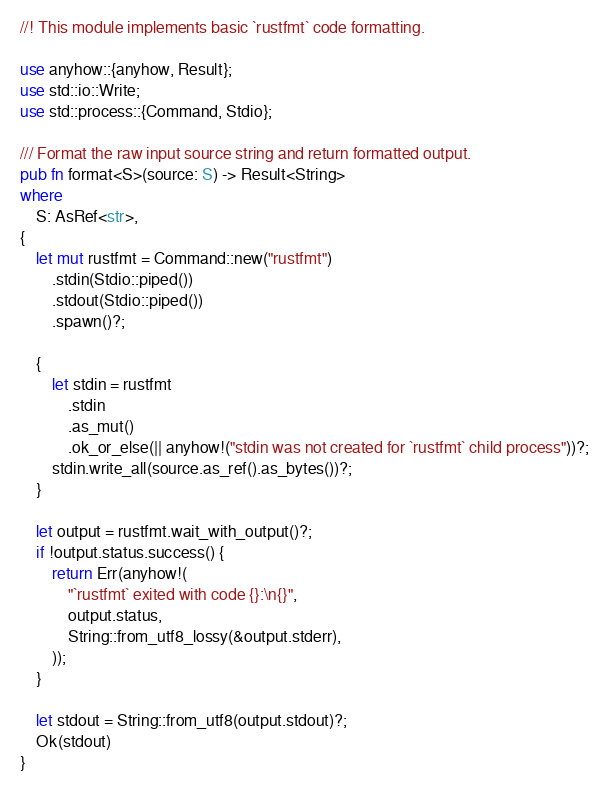<code> <loc_0><loc_0><loc_500><loc_500><_Rust_>//! This module implements basic `rustfmt` code formatting.

use anyhow::{anyhow, Result};
use std::io::Write;
use std::process::{Command, Stdio};

/// Format the raw input source string and return formatted output.
pub fn format<S>(source: S) -> Result<String>
where
    S: AsRef<str>,
{
    let mut rustfmt = Command::new("rustfmt")
        .stdin(Stdio::piped())
        .stdout(Stdio::piped())
        .spawn()?;

    {
        let stdin = rustfmt
            .stdin
            .as_mut()
            .ok_or_else(|| anyhow!("stdin was not created for `rustfmt` child process"))?;
        stdin.write_all(source.as_ref().as_bytes())?;
    }

    let output = rustfmt.wait_with_output()?;
    if !output.status.success() {
        return Err(anyhow!(
            "`rustfmt` exited with code {}:\n{}",
            output.status,
            String::from_utf8_lossy(&output.stderr),
        ));
    }

    let stdout = String::from_utf8(output.stdout)?;
    Ok(stdout)
}
</code> 